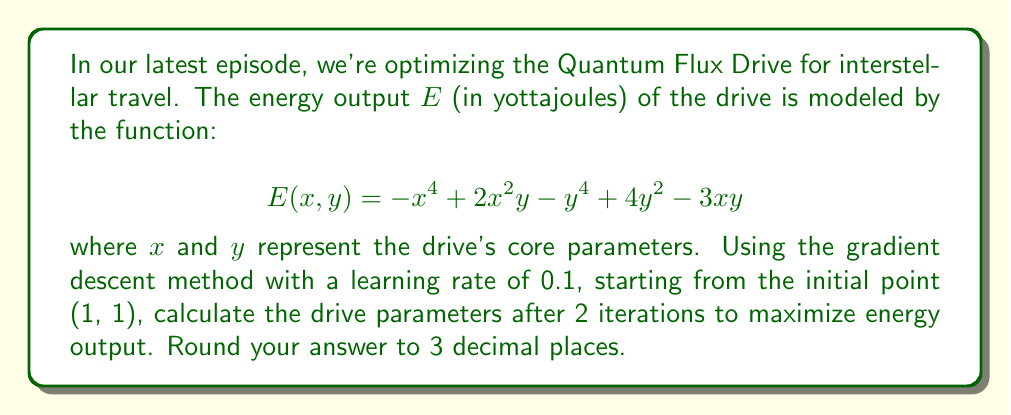Help me with this question. To optimize the energy output using gradient descent, we follow these steps:

1) First, we need to calculate the gradient of $E(x, y)$:

   $\frac{\partial E}{\partial x} = -4x^3 + 4xy - 3y$
   $\frac{\partial E}{\partial y} = 2x^2 - 4y^3 + 8y - 3x$

2) The gradient descent update rule is:

   $x_{n+1} = x_n + \alpha \frac{\partial E}{\partial x}$
   $y_{n+1} = y_n + \alpha \frac{\partial E}{\partial y}$

   where $\alpha = 0.1$ is the learning rate.

3) Starting point: $(x_0, y_0) = (1, 1)$

4) First iteration:

   $\frac{\partial E}{\partial x} = -4(1)^3 + 4(1)(1) - 3(1) = -3$
   $\frac{\partial E}{\partial y} = 2(1)^2 - 4(1)^3 + 8(1) - 3(1) = 3$

   $x_1 = 1 + 0.1(-3) = 0.7$
   $y_1 = 1 + 0.1(3) = 1.3$

5) Second iteration:

   $\frac{\partial E}{\partial x} = -4(0.7)^3 + 4(0.7)(1.3) - 3(1.3) = -0.7658$
   $\frac{\partial E}{\partial y} = 2(0.7)^2 - 4(1.3)^3 + 8(1.3) - 3(0.7) = -2.2498$

   $x_2 = 0.7 + 0.1(-0.7658) = 0.6234$
   $y_2 = 1.3 + 0.1(-2.2498) = 1.0750$

6) Rounding to 3 decimal places:
   $(x_2, y_2) = (0.623, 1.075)$
Answer: (0.623, 1.075) 